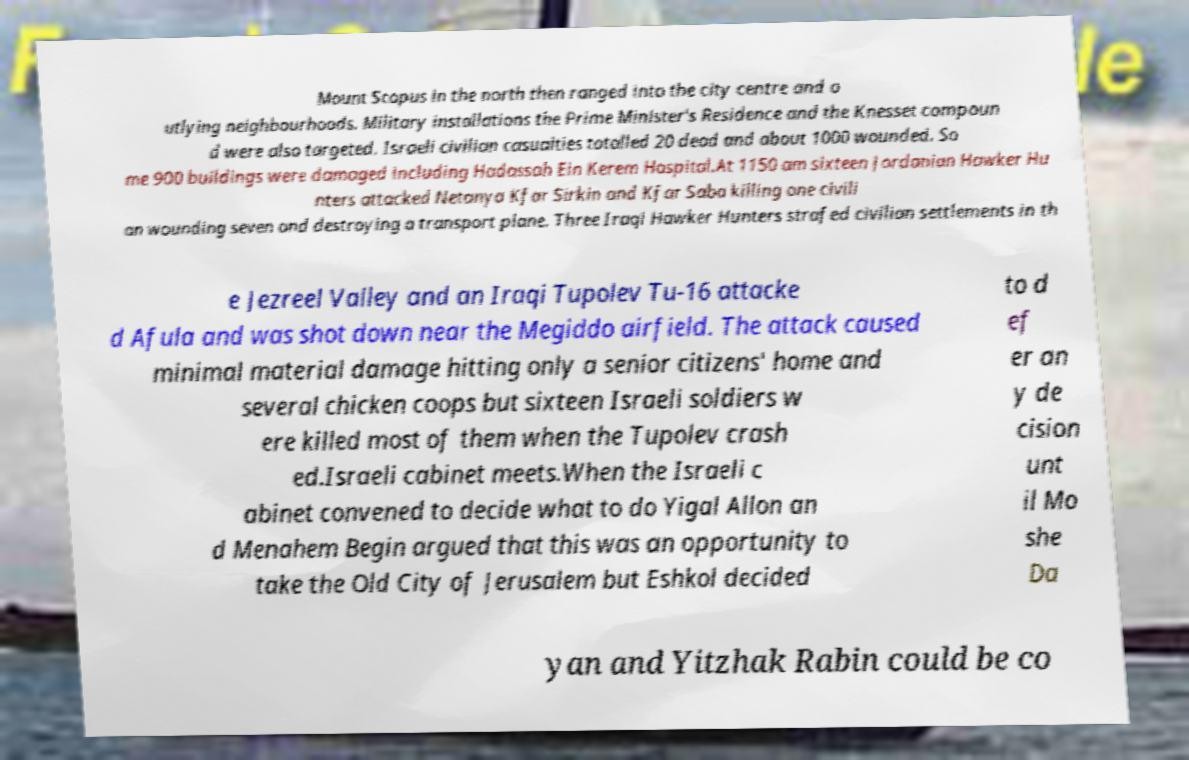Could you extract and type out the text from this image? Mount Scopus in the north then ranged into the city centre and o utlying neighbourhoods. Military installations the Prime Minister's Residence and the Knesset compoun d were also targeted. Israeli civilian casualties totalled 20 dead and about 1000 wounded. So me 900 buildings were damaged including Hadassah Ein Kerem Hospital.At 1150 am sixteen Jordanian Hawker Hu nters attacked Netanya Kfar Sirkin and Kfar Saba killing one civili an wounding seven and destroying a transport plane. Three Iraqi Hawker Hunters strafed civilian settlements in th e Jezreel Valley and an Iraqi Tupolev Tu-16 attacke d Afula and was shot down near the Megiddo airfield. The attack caused minimal material damage hitting only a senior citizens' home and several chicken coops but sixteen Israeli soldiers w ere killed most of them when the Tupolev crash ed.Israeli cabinet meets.When the Israeli c abinet convened to decide what to do Yigal Allon an d Menahem Begin argued that this was an opportunity to take the Old City of Jerusalem but Eshkol decided to d ef er an y de cision unt il Mo she Da yan and Yitzhak Rabin could be co 